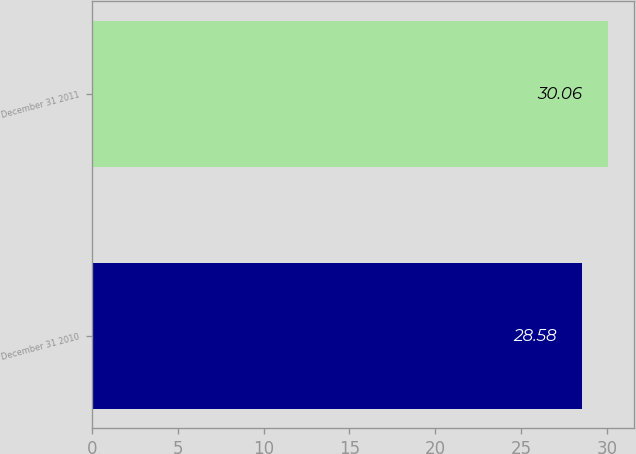<chart> <loc_0><loc_0><loc_500><loc_500><bar_chart><fcel>December 31 2010<fcel>December 31 2011<nl><fcel>28.58<fcel>30.06<nl></chart> 